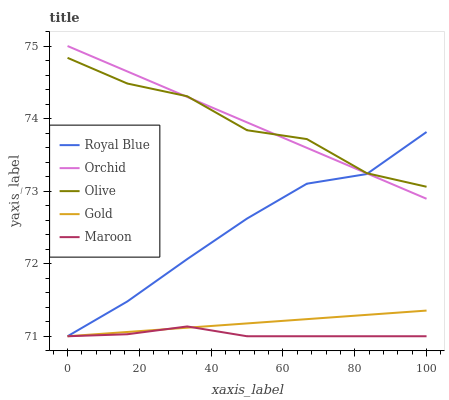Does Maroon have the minimum area under the curve?
Answer yes or no. Yes. Does Orchid have the maximum area under the curve?
Answer yes or no. Yes. Does Royal Blue have the minimum area under the curve?
Answer yes or no. No. Does Royal Blue have the maximum area under the curve?
Answer yes or no. No. Is Gold the smoothest?
Answer yes or no. Yes. Is Olive the roughest?
Answer yes or no. Yes. Is Royal Blue the smoothest?
Answer yes or no. No. Is Royal Blue the roughest?
Answer yes or no. No. Does Orchid have the lowest value?
Answer yes or no. No. Does Orchid have the highest value?
Answer yes or no. Yes. Does Royal Blue have the highest value?
Answer yes or no. No. Is Maroon less than Orchid?
Answer yes or no. Yes. Is Orchid greater than Maroon?
Answer yes or no. Yes. Does Gold intersect Maroon?
Answer yes or no. Yes. Is Gold less than Maroon?
Answer yes or no. No. Is Gold greater than Maroon?
Answer yes or no. No. Does Maroon intersect Orchid?
Answer yes or no. No. 